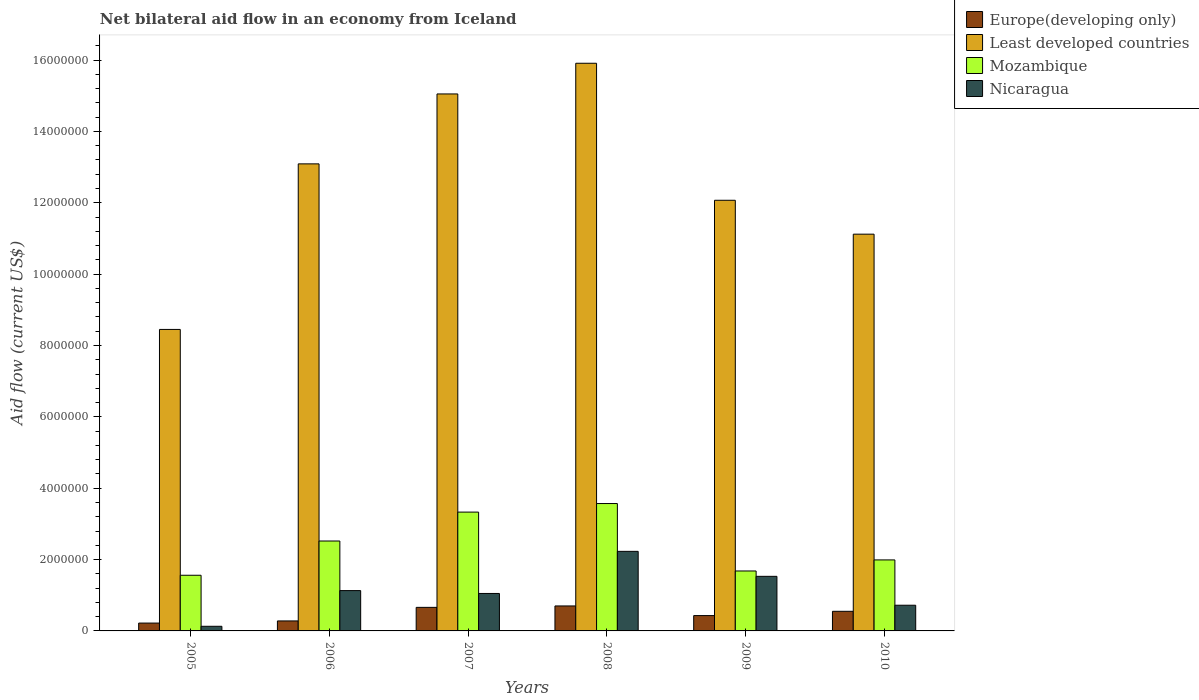How many different coloured bars are there?
Your response must be concise. 4. How many groups of bars are there?
Provide a short and direct response. 6. Are the number of bars per tick equal to the number of legend labels?
Provide a succinct answer. Yes. Are the number of bars on each tick of the X-axis equal?
Provide a succinct answer. Yes. How many bars are there on the 2nd tick from the right?
Make the answer very short. 4. What is the label of the 5th group of bars from the left?
Provide a succinct answer. 2009. What is the net bilateral aid flow in Least developed countries in 2006?
Offer a very short reply. 1.31e+07. Across all years, what is the maximum net bilateral aid flow in Mozambique?
Your answer should be very brief. 3.57e+06. What is the total net bilateral aid flow in Least developed countries in the graph?
Your answer should be compact. 7.57e+07. What is the difference between the net bilateral aid flow in Nicaragua in 2009 and that in 2010?
Offer a terse response. 8.10e+05. What is the difference between the net bilateral aid flow in Nicaragua in 2008 and the net bilateral aid flow in Least developed countries in 2006?
Keep it short and to the point. -1.09e+07. What is the average net bilateral aid flow in Nicaragua per year?
Your response must be concise. 1.13e+06. In the year 2006, what is the difference between the net bilateral aid flow in Mozambique and net bilateral aid flow in Nicaragua?
Your response must be concise. 1.39e+06. What is the ratio of the net bilateral aid flow in Nicaragua in 2007 to that in 2008?
Offer a very short reply. 0.47. Is the net bilateral aid flow in Europe(developing only) in 2008 less than that in 2009?
Keep it short and to the point. No. Is the difference between the net bilateral aid flow in Mozambique in 2009 and 2010 greater than the difference between the net bilateral aid flow in Nicaragua in 2009 and 2010?
Offer a terse response. No. What is the difference between the highest and the second highest net bilateral aid flow in Least developed countries?
Your answer should be very brief. 8.60e+05. What is the difference between the highest and the lowest net bilateral aid flow in Nicaragua?
Your response must be concise. 2.10e+06. Is the sum of the net bilateral aid flow in Mozambique in 2006 and 2009 greater than the maximum net bilateral aid flow in Least developed countries across all years?
Give a very brief answer. No. What does the 3rd bar from the left in 2005 represents?
Offer a terse response. Mozambique. What does the 3rd bar from the right in 2008 represents?
Give a very brief answer. Least developed countries. Does the graph contain any zero values?
Provide a succinct answer. No. Does the graph contain grids?
Your response must be concise. No. How are the legend labels stacked?
Make the answer very short. Vertical. What is the title of the graph?
Ensure brevity in your answer.  Net bilateral aid flow in an economy from Iceland. What is the label or title of the X-axis?
Give a very brief answer. Years. What is the Aid flow (current US$) of Europe(developing only) in 2005?
Make the answer very short. 2.20e+05. What is the Aid flow (current US$) in Least developed countries in 2005?
Your answer should be very brief. 8.45e+06. What is the Aid flow (current US$) in Mozambique in 2005?
Give a very brief answer. 1.56e+06. What is the Aid flow (current US$) in Least developed countries in 2006?
Offer a very short reply. 1.31e+07. What is the Aid flow (current US$) of Mozambique in 2006?
Offer a very short reply. 2.52e+06. What is the Aid flow (current US$) in Nicaragua in 2006?
Keep it short and to the point. 1.13e+06. What is the Aid flow (current US$) in Least developed countries in 2007?
Your answer should be very brief. 1.50e+07. What is the Aid flow (current US$) of Mozambique in 2007?
Your answer should be compact. 3.33e+06. What is the Aid flow (current US$) in Nicaragua in 2007?
Provide a succinct answer. 1.05e+06. What is the Aid flow (current US$) in Europe(developing only) in 2008?
Keep it short and to the point. 7.00e+05. What is the Aid flow (current US$) in Least developed countries in 2008?
Your response must be concise. 1.59e+07. What is the Aid flow (current US$) in Mozambique in 2008?
Offer a very short reply. 3.57e+06. What is the Aid flow (current US$) in Nicaragua in 2008?
Provide a short and direct response. 2.23e+06. What is the Aid flow (current US$) in Least developed countries in 2009?
Provide a short and direct response. 1.21e+07. What is the Aid flow (current US$) in Mozambique in 2009?
Make the answer very short. 1.68e+06. What is the Aid flow (current US$) in Nicaragua in 2009?
Your answer should be compact. 1.53e+06. What is the Aid flow (current US$) of Europe(developing only) in 2010?
Offer a terse response. 5.50e+05. What is the Aid flow (current US$) in Least developed countries in 2010?
Offer a terse response. 1.11e+07. What is the Aid flow (current US$) in Mozambique in 2010?
Offer a very short reply. 1.99e+06. What is the Aid flow (current US$) in Nicaragua in 2010?
Give a very brief answer. 7.20e+05. Across all years, what is the maximum Aid flow (current US$) of Europe(developing only)?
Provide a short and direct response. 7.00e+05. Across all years, what is the maximum Aid flow (current US$) of Least developed countries?
Give a very brief answer. 1.59e+07. Across all years, what is the maximum Aid flow (current US$) in Mozambique?
Provide a short and direct response. 3.57e+06. Across all years, what is the maximum Aid flow (current US$) in Nicaragua?
Make the answer very short. 2.23e+06. Across all years, what is the minimum Aid flow (current US$) of Least developed countries?
Provide a short and direct response. 8.45e+06. Across all years, what is the minimum Aid flow (current US$) of Mozambique?
Your response must be concise. 1.56e+06. Across all years, what is the minimum Aid flow (current US$) in Nicaragua?
Make the answer very short. 1.30e+05. What is the total Aid flow (current US$) in Europe(developing only) in the graph?
Ensure brevity in your answer.  2.84e+06. What is the total Aid flow (current US$) of Least developed countries in the graph?
Provide a succinct answer. 7.57e+07. What is the total Aid flow (current US$) of Mozambique in the graph?
Your answer should be very brief. 1.46e+07. What is the total Aid flow (current US$) of Nicaragua in the graph?
Provide a succinct answer. 6.79e+06. What is the difference between the Aid flow (current US$) in Europe(developing only) in 2005 and that in 2006?
Your answer should be very brief. -6.00e+04. What is the difference between the Aid flow (current US$) in Least developed countries in 2005 and that in 2006?
Ensure brevity in your answer.  -4.64e+06. What is the difference between the Aid flow (current US$) of Mozambique in 2005 and that in 2006?
Offer a terse response. -9.60e+05. What is the difference between the Aid flow (current US$) of Europe(developing only) in 2005 and that in 2007?
Ensure brevity in your answer.  -4.40e+05. What is the difference between the Aid flow (current US$) of Least developed countries in 2005 and that in 2007?
Your answer should be compact. -6.60e+06. What is the difference between the Aid flow (current US$) of Mozambique in 2005 and that in 2007?
Give a very brief answer. -1.77e+06. What is the difference between the Aid flow (current US$) of Nicaragua in 2005 and that in 2007?
Offer a terse response. -9.20e+05. What is the difference between the Aid flow (current US$) of Europe(developing only) in 2005 and that in 2008?
Provide a short and direct response. -4.80e+05. What is the difference between the Aid flow (current US$) in Least developed countries in 2005 and that in 2008?
Provide a short and direct response. -7.46e+06. What is the difference between the Aid flow (current US$) in Mozambique in 2005 and that in 2008?
Your answer should be compact. -2.01e+06. What is the difference between the Aid flow (current US$) of Nicaragua in 2005 and that in 2008?
Ensure brevity in your answer.  -2.10e+06. What is the difference between the Aid flow (current US$) in Least developed countries in 2005 and that in 2009?
Provide a short and direct response. -3.62e+06. What is the difference between the Aid flow (current US$) in Mozambique in 2005 and that in 2009?
Offer a terse response. -1.20e+05. What is the difference between the Aid flow (current US$) of Nicaragua in 2005 and that in 2009?
Your response must be concise. -1.40e+06. What is the difference between the Aid flow (current US$) of Europe(developing only) in 2005 and that in 2010?
Your answer should be very brief. -3.30e+05. What is the difference between the Aid flow (current US$) of Least developed countries in 2005 and that in 2010?
Give a very brief answer. -2.67e+06. What is the difference between the Aid flow (current US$) in Mozambique in 2005 and that in 2010?
Your answer should be very brief. -4.30e+05. What is the difference between the Aid flow (current US$) of Nicaragua in 2005 and that in 2010?
Your response must be concise. -5.90e+05. What is the difference between the Aid flow (current US$) in Europe(developing only) in 2006 and that in 2007?
Your response must be concise. -3.80e+05. What is the difference between the Aid flow (current US$) in Least developed countries in 2006 and that in 2007?
Your answer should be very brief. -1.96e+06. What is the difference between the Aid flow (current US$) in Mozambique in 2006 and that in 2007?
Your answer should be very brief. -8.10e+05. What is the difference between the Aid flow (current US$) of Europe(developing only) in 2006 and that in 2008?
Ensure brevity in your answer.  -4.20e+05. What is the difference between the Aid flow (current US$) in Least developed countries in 2006 and that in 2008?
Offer a very short reply. -2.82e+06. What is the difference between the Aid flow (current US$) of Mozambique in 2006 and that in 2008?
Provide a short and direct response. -1.05e+06. What is the difference between the Aid flow (current US$) of Nicaragua in 2006 and that in 2008?
Provide a succinct answer. -1.10e+06. What is the difference between the Aid flow (current US$) of Europe(developing only) in 2006 and that in 2009?
Your answer should be compact. -1.50e+05. What is the difference between the Aid flow (current US$) of Least developed countries in 2006 and that in 2009?
Keep it short and to the point. 1.02e+06. What is the difference between the Aid flow (current US$) of Mozambique in 2006 and that in 2009?
Your answer should be compact. 8.40e+05. What is the difference between the Aid flow (current US$) in Nicaragua in 2006 and that in 2009?
Give a very brief answer. -4.00e+05. What is the difference between the Aid flow (current US$) in Europe(developing only) in 2006 and that in 2010?
Your response must be concise. -2.70e+05. What is the difference between the Aid flow (current US$) in Least developed countries in 2006 and that in 2010?
Provide a succinct answer. 1.97e+06. What is the difference between the Aid flow (current US$) of Mozambique in 2006 and that in 2010?
Give a very brief answer. 5.30e+05. What is the difference between the Aid flow (current US$) in Nicaragua in 2006 and that in 2010?
Provide a succinct answer. 4.10e+05. What is the difference between the Aid flow (current US$) of Europe(developing only) in 2007 and that in 2008?
Provide a short and direct response. -4.00e+04. What is the difference between the Aid flow (current US$) of Least developed countries in 2007 and that in 2008?
Your answer should be compact. -8.60e+05. What is the difference between the Aid flow (current US$) in Nicaragua in 2007 and that in 2008?
Give a very brief answer. -1.18e+06. What is the difference between the Aid flow (current US$) of Least developed countries in 2007 and that in 2009?
Your answer should be compact. 2.98e+06. What is the difference between the Aid flow (current US$) of Mozambique in 2007 and that in 2009?
Give a very brief answer. 1.65e+06. What is the difference between the Aid flow (current US$) in Nicaragua in 2007 and that in 2009?
Provide a succinct answer. -4.80e+05. What is the difference between the Aid flow (current US$) of Europe(developing only) in 2007 and that in 2010?
Offer a very short reply. 1.10e+05. What is the difference between the Aid flow (current US$) in Least developed countries in 2007 and that in 2010?
Your response must be concise. 3.93e+06. What is the difference between the Aid flow (current US$) of Mozambique in 2007 and that in 2010?
Your answer should be compact. 1.34e+06. What is the difference between the Aid flow (current US$) of Europe(developing only) in 2008 and that in 2009?
Keep it short and to the point. 2.70e+05. What is the difference between the Aid flow (current US$) in Least developed countries in 2008 and that in 2009?
Your response must be concise. 3.84e+06. What is the difference between the Aid flow (current US$) of Mozambique in 2008 and that in 2009?
Provide a succinct answer. 1.89e+06. What is the difference between the Aid flow (current US$) of Nicaragua in 2008 and that in 2009?
Provide a succinct answer. 7.00e+05. What is the difference between the Aid flow (current US$) in Europe(developing only) in 2008 and that in 2010?
Give a very brief answer. 1.50e+05. What is the difference between the Aid flow (current US$) in Least developed countries in 2008 and that in 2010?
Offer a very short reply. 4.79e+06. What is the difference between the Aid flow (current US$) of Mozambique in 2008 and that in 2010?
Make the answer very short. 1.58e+06. What is the difference between the Aid flow (current US$) in Nicaragua in 2008 and that in 2010?
Ensure brevity in your answer.  1.51e+06. What is the difference between the Aid flow (current US$) of Europe(developing only) in 2009 and that in 2010?
Give a very brief answer. -1.20e+05. What is the difference between the Aid flow (current US$) of Least developed countries in 2009 and that in 2010?
Ensure brevity in your answer.  9.50e+05. What is the difference between the Aid flow (current US$) in Mozambique in 2009 and that in 2010?
Make the answer very short. -3.10e+05. What is the difference between the Aid flow (current US$) of Nicaragua in 2009 and that in 2010?
Your answer should be compact. 8.10e+05. What is the difference between the Aid flow (current US$) in Europe(developing only) in 2005 and the Aid flow (current US$) in Least developed countries in 2006?
Make the answer very short. -1.29e+07. What is the difference between the Aid flow (current US$) in Europe(developing only) in 2005 and the Aid flow (current US$) in Mozambique in 2006?
Offer a very short reply. -2.30e+06. What is the difference between the Aid flow (current US$) in Europe(developing only) in 2005 and the Aid flow (current US$) in Nicaragua in 2006?
Give a very brief answer. -9.10e+05. What is the difference between the Aid flow (current US$) in Least developed countries in 2005 and the Aid flow (current US$) in Mozambique in 2006?
Ensure brevity in your answer.  5.93e+06. What is the difference between the Aid flow (current US$) in Least developed countries in 2005 and the Aid flow (current US$) in Nicaragua in 2006?
Provide a succinct answer. 7.32e+06. What is the difference between the Aid flow (current US$) of Europe(developing only) in 2005 and the Aid flow (current US$) of Least developed countries in 2007?
Offer a terse response. -1.48e+07. What is the difference between the Aid flow (current US$) in Europe(developing only) in 2005 and the Aid flow (current US$) in Mozambique in 2007?
Make the answer very short. -3.11e+06. What is the difference between the Aid flow (current US$) of Europe(developing only) in 2005 and the Aid flow (current US$) of Nicaragua in 2007?
Offer a very short reply. -8.30e+05. What is the difference between the Aid flow (current US$) of Least developed countries in 2005 and the Aid flow (current US$) of Mozambique in 2007?
Give a very brief answer. 5.12e+06. What is the difference between the Aid flow (current US$) in Least developed countries in 2005 and the Aid flow (current US$) in Nicaragua in 2007?
Your response must be concise. 7.40e+06. What is the difference between the Aid flow (current US$) of Mozambique in 2005 and the Aid flow (current US$) of Nicaragua in 2007?
Provide a short and direct response. 5.10e+05. What is the difference between the Aid flow (current US$) of Europe(developing only) in 2005 and the Aid flow (current US$) of Least developed countries in 2008?
Your answer should be very brief. -1.57e+07. What is the difference between the Aid flow (current US$) of Europe(developing only) in 2005 and the Aid flow (current US$) of Mozambique in 2008?
Offer a very short reply. -3.35e+06. What is the difference between the Aid flow (current US$) of Europe(developing only) in 2005 and the Aid flow (current US$) of Nicaragua in 2008?
Provide a short and direct response. -2.01e+06. What is the difference between the Aid flow (current US$) of Least developed countries in 2005 and the Aid flow (current US$) of Mozambique in 2008?
Make the answer very short. 4.88e+06. What is the difference between the Aid flow (current US$) of Least developed countries in 2005 and the Aid flow (current US$) of Nicaragua in 2008?
Make the answer very short. 6.22e+06. What is the difference between the Aid flow (current US$) of Mozambique in 2005 and the Aid flow (current US$) of Nicaragua in 2008?
Provide a short and direct response. -6.70e+05. What is the difference between the Aid flow (current US$) of Europe(developing only) in 2005 and the Aid flow (current US$) of Least developed countries in 2009?
Offer a terse response. -1.18e+07. What is the difference between the Aid flow (current US$) in Europe(developing only) in 2005 and the Aid flow (current US$) in Mozambique in 2009?
Provide a short and direct response. -1.46e+06. What is the difference between the Aid flow (current US$) of Europe(developing only) in 2005 and the Aid flow (current US$) of Nicaragua in 2009?
Provide a succinct answer. -1.31e+06. What is the difference between the Aid flow (current US$) in Least developed countries in 2005 and the Aid flow (current US$) in Mozambique in 2009?
Make the answer very short. 6.77e+06. What is the difference between the Aid flow (current US$) in Least developed countries in 2005 and the Aid flow (current US$) in Nicaragua in 2009?
Provide a short and direct response. 6.92e+06. What is the difference between the Aid flow (current US$) in Europe(developing only) in 2005 and the Aid flow (current US$) in Least developed countries in 2010?
Keep it short and to the point. -1.09e+07. What is the difference between the Aid flow (current US$) of Europe(developing only) in 2005 and the Aid flow (current US$) of Mozambique in 2010?
Offer a very short reply. -1.77e+06. What is the difference between the Aid flow (current US$) in Europe(developing only) in 2005 and the Aid flow (current US$) in Nicaragua in 2010?
Provide a succinct answer. -5.00e+05. What is the difference between the Aid flow (current US$) of Least developed countries in 2005 and the Aid flow (current US$) of Mozambique in 2010?
Offer a very short reply. 6.46e+06. What is the difference between the Aid flow (current US$) of Least developed countries in 2005 and the Aid flow (current US$) of Nicaragua in 2010?
Ensure brevity in your answer.  7.73e+06. What is the difference between the Aid flow (current US$) in Mozambique in 2005 and the Aid flow (current US$) in Nicaragua in 2010?
Your answer should be compact. 8.40e+05. What is the difference between the Aid flow (current US$) in Europe(developing only) in 2006 and the Aid flow (current US$) in Least developed countries in 2007?
Provide a short and direct response. -1.48e+07. What is the difference between the Aid flow (current US$) of Europe(developing only) in 2006 and the Aid flow (current US$) of Mozambique in 2007?
Provide a short and direct response. -3.05e+06. What is the difference between the Aid flow (current US$) of Europe(developing only) in 2006 and the Aid flow (current US$) of Nicaragua in 2007?
Give a very brief answer. -7.70e+05. What is the difference between the Aid flow (current US$) of Least developed countries in 2006 and the Aid flow (current US$) of Mozambique in 2007?
Your answer should be compact. 9.76e+06. What is the difference between the Aid flow (current US$) in Least developed countries in 2006 and the Aid flow (current US$) in Nicaragua in 2007?
Ensure brevity in your answer.  1.20e+07. What is the difference between the Aid flow (current US$) of Mozambique in 2006 and the Aid flow (current US$) of Nicaragua in 2007?
Offer a terse response. 1.47e+06. What is the difference between the Aid flow (current US$) in Europe(developing only) in 2006 and the Aid flow (current US$) in Least developed countries in 2008?
Your answer should be very brief. -1.56e+07. What is the difference between the Aid flow (current US$) in Europe(developing only) in 2006 and the Aid flow (current US$) in Mozambique in 2008?
Provide a short and direct response. -3.29e+06. What is the difference between the Aid flow (current US$) of Europe(developing only) in 2006 and the Aid flow (current US$) of Nicaragua in 2008?
Offer a very short reply. -1.95e+06. What is the difference between the Aid flow (current US$) in Least developed countries in 2006 and the Aid flow (current US$) in Mozambique in 2008?
Ensure brevity in your answer.  9.52e+06. What is the difference between the Aid flow (current US$) of Least developed countries in 2006 and the Aid flow (current US$) of Nicaragua in 2008?
Your answer should be very brief. 1.09e+07. What is the difference between the Aid flow (current US$) in Europe(developing only) in 2006 and the Aid flow (current US$) in Least developed countries in 2009?
Your answer should be very brief. -1.18e+07. What is the difference between the Aid flow (current US$) in Europe(developing only) in 2006 and the Aid flow (current US$) in Mozambique in 2009?
Your answer should be compact. -1.40e+06. What is the difference between the Aid flow (current US$) in Europe(developing only) in 2006 and the Aid flow (current US$) in Nicaragua in 2009?
Provide a short and direct response. -1.25e+06. What is the difference between the Aid flow (current US$) of Least developed countries in 2006 and the Aid flow (current US$) of Mozambique in 2009?
Provide a short and direct response. 1.14e+07. What is the difference between the Aid flow (current US$) in Least developed countries in 2006 and the Aid flow (current US$) in Nicaragua in 2009?
Your response must be concise. 1.16e+07. What is the difference between the Aid flow (current US$) in Mozambique in 2006 and the Aid flow (current US$) in Nicaragua in 2009?
Keep it short and to the point. 9.90e+05. What is the difference between the Aid flow (current US$) of Europe(developing only) in 2006 and the Aid flow (current US$) of Least developed countries in 2010?
Your response must be concise. -1.08e+07. What is the difference between the Aid flow (current US$) in Europe(developing only) in 2006 and the Aid flow (current US$) in Mozambique in 2010?
Offer a very short reply. -1.71e+06. What is the difference between the Aid flow (current US$) in Europe(developing only) in 2006 and the Aid flow (current US$) in Nicaragua in 2010?
Keep it short and to the point. -4.40e+05. What is the difference between the Aid flow (current US$) in Least developed countries in 2006 and the Aid flow (current US$) in Mozambique in 2010?
Provide a short and direct response. 1.11e+07. What is the difference between the Aid flow (current US$) in Least developed countries in 2006 and the Aid flow (current US$) in Nicaragua in 2010?
Keep it short and to the point. 1.24e+07. What is the difference between the Aid flow (current US$) in Mozambique in 2006 and the Aid flow (current US$) in Nicaragua in 2010?
Provide a succinct answer. 1.80e+06. What is the difference between the Aid flow (current US$) in Europe(developing only) in 2007 and the Aid flow (current US$) in Least developed countries in 2008?
Your answer should be very brief. -1.52e+07. What is the difference between the Aid flow (current US$) in Europe(developing only) in 2007 and the Aid flow (current US$) in Mozambique in 2008?
Provide a succinct answer. -2.91e+06. What is the difference between the Aid flow (current US$) in Europe(developing only) in 2007 and the Aid flow (current US$) in Nicaragua in 2008?
Your answer should be compact. -1.57e+06. What is the difference between the Aid flow (current US$) of Least developed countries in 2007 and the Aid flow (current US$) of Mozambique in 2008?
Make the answer very short. 1.15e+07. What is the difference between the Aid flow (current US$) of Least developed countries in 2007 and the Aid flow (current US$) of Nicaragua in 2008?
Provide a short and direct response. 1.28e+07. What is the difference between the Aid flow (current US$) in Mozambique in 2007 and the Aid flow (current US$) in Nicaragua in 2008?
Make the answer very short. 1.10e+06. What is the difference between the Aid flow (current US$) of Europe(developing only) in 2007 and the Aid flow (current US$) of Least developed countries in 2009?
Offer a terse response. -1.14e+07. What is the difference between the Aid flow (current US$) in Europe(developing only) in 2007 and the Aid flow (current US$) in Mozambique in 2009?
Offer a very short reply. -1.02e+06. What is the difference between the Aid flow (current US$) in Europe(developing only) in 2007 and the Aid flow (current US$) in Nicaragua in 2009?
Your answer should be compact. -8.70e+05. What is the difference between the Aid flow (current US$) in Least developed countries in 2007 and the Aid flow (current US$) in Mozambique in 2009?
Your answer should be compact. 1.34e+07. What is the difference between the Aid flow (current US$) of Least developed countries in 2007 and the Aid flow (current US$) of Nicaragua in 2009?
Ensure brevity in your answer.  1.35e+07. What is the difference between the Aid flow (current US$) in Mozambique in 2007 and the Aid flow (current US$) in Nicaragua in 2009?
Give a very brief answer. 1.80e+06. What is the difference between the Aid flow (current US$) in Europe(developing only) in 2007 and the Aid flow (current US$) in Least developed countries in 2010?
Make the answer very short. -1.05e+07. What is the difference between the Aid flow (current US$) of Europe(developing only) in 2007 and the Aid flow (current US$) of Mozambique in 2010?
Keep it short and to the point. -1.33e+06. What is the difference between the Aid flow (current US$) of Europe(developing only) in 2007 and the Aid flow (current US$) of Nicaragua in 2010?
Your response must be concise. -6.00e+04. What is the difference between the Aid flow (current US$) in Least developed countries in 2007 and the Aid flow (current US$) in Mozambique in 2010?
Offer a terse response. 1.31e+07. What is the difference between the Aid flow (current US$) in Least developed countries in 2007 and the Aid flow (current US$) in Nicaragua in 2010?
Offer a very short reply. 1.43e+07. What is the difference between the Aid flow (current US$) of Mozambique in 2007 and the Aid flow (current US$) of Nicaragua in 2010?
Provide a succinct answer. 2.61e+06. What is the difference between the Aid flow (current US$) of Europe(developing only) in 2008 and the Aid flow (current US$) of Least developed countries in 2009?
Your response must be concise. -1.14e+07. What is the difference between the Aid flow (current US$) in Europe(developing only) in 2008 and the Aid flow (current US$) in Mozambique in 2009?
Ensure brevity in your answer.  -9.80e+05. What is the difference between the Aid flow (current US$) in Europe(developing only) in 2008 and the Aid flow (current US$) in Nicaragua in 2009?
Offer a very short reply. -8.30e+05. What is the difference between the Aid flow (current US$) of Least developed countries in 2008 and the Aid flow (current US$) of Mozambique in 2009?
Your answer should be very brief. 1.42e+07. What is the difference between the Aid flow (current US$) of Least developed countries in 2008 and the Aid flow (current US$) of Nicaragua in 2009?
Your response must be concise. 1.44e+07. What is the difference between the Aid flow (current US$) of Mozambique in 2008 and the Aid flow (current US$) of Nicaragua in 2009?
Give a very brief answer. 2.04e+06. What is the difference between the Aid flow (current US$) in Europe(developing only) in 2008 and the Aid flow (current US$) in Least developed countries in 2010?
Give a very brief answer. -1.04e+07. What is the difference between the Aid flow (current US$) in Europe(developing only) in 2008 and the Aid flow (current US$) in Mozambique in 2010?
Provide a short and direct response. -1.29e+06. What is the difference between the Aid flow (current US$) of Europe(developing only) in 2008 and the Aid flow (current US$) of Nicaragua in 2010?
Provide a short and direct response. -2.00e+04. What is the difference between the Aid flow (current US$) of Least developed countries in 2008 and the Aid flow (current US$) of Mozambique in 2010?
Ensure brevity in your answer.  1.39e+07. What is the difference between the Aid flow (current US$) in Least developed countries in 2008 and the Aid flow (current US$) in Nicaragua in 2010?
Your answer should be very brief. 1.52e+07. What is the difference between the Aid flow (current US$) of Mozambique in 2008 and the Aid flow (current US$) of Nicaragua in 2010?
Your answer should be compact. 2.85e+06. What is the difference between the Aid flow (current US$) in Europe(developing only) in 2009 and the Aid flow (current US$) in Least developed countries in 2010?
Offer a terse response. -1.07e+07. What is the difference between the Aid flow (current US$) of Europe(developing only) in 2009 and the Aid flow (current US$) of Mozambique in 2010?
Offer a very short reply. -1.56e+06. What is the difference between the Aid flow (current US$) of Europe(developing only) in 2009 and the Aid flow (current US$) of Nicaragua in 2010?
Your answer should be very brief. -2.90e+05. What is the difference between the Aid flow (current US$) in Least developed countries in 2009 and the Aid flow (current US$) in Mozambique in 2010?
Offer a very short reply. 1.01e+07. What is the difference between the Aid flow (current US$) in Least developed countries in 2009 and the Aid flow (current US$) in Nicaragua in 2010?
Offer a terse response. 1.14e+07. What is the difference between the Aid flow (current US$) in Mozambique in 2009 and the Aid flow (current US$) in Nicaragua in 2010?
Provide a short and direct response. 9.60e+05. What is the average Aid flow (current US$) of Europe(developing only) per year?
Your answer should be compact. 4.73e+05. What is the average Aid flow (current US$) in Least developed countries per year?
Keep it short and to the point. 1.26e+07. What is the average Aid flow (current US$) of Mozambique per year?
Your answer should be compact. 2.44e+06. What is the average Aid flow (current US$) of Nicaragua per year?
Provide a short and direct response. 1.13e+06. In the year 2005, what is the difference between the Aid flow (current US$) in Europe(developing only) and Aid flow (current US$) in Least developed countries?
Keep it short and to the point. -8.23e+06. In the year 2005, what is the difference between the Aid flow (current US$) in Europe(developing only) and Aid flow (current US$) in Mozambique?
Your answer should be compact. -1.34e+06. In the year 2005, what is the difference between the Aid flow (current US$) in Least developed countries and Aid flow (current US$) in Mozambique?
Keep it short and to the point. 6.89e+06. In the year 2005, what is the difference between the Aid flow (current US$) of Least developed countries and Aid flow (current US$) of Nicaragua?
Ensure brevity in your answer.  8.32e+06. In the year 2005, what is the difference between the Aid flow (current US$) in Mozambique and Aid flow (current US$) in Nicaragua?
Your answer should be very brief. 1.43e+06. In the year 2006, what is the difference between the Aid flow (current US$) in Europe(developing only) and Aid flow (current US$) in Least developed countries?
Provide a short and direct response. -1.28e+07. In the year 2006, what is the difference between the Aid flow (current US$) in Europe(developing only) and Aid flow (current US$) in Mozambique?
Keep it short and to the point. -2.24e+06. In the year 2006, what is the difference between the Aid flow (current US$) in Europe(developing only) and Aid flow (current US$) in Nicaragua?
Give a very brief answer. -8.50e+05. In the year 2006, what is the difference between the Aid flow (current US$) of Least developed countries and Aid flow (current US$) of Mozambique?
Give a very brief answer. 1.06e+07. In the year 2006, what is the difference between the Aid flow (current US$) of Least developed countries and Aid flow (current US$) of Nicaragua?
Your answer should be very brief. 1.20e+07. In the year 2006, what is the difference between the Aid flow (current US$) of Mozambique and Aid flow (current US$) of Nicaragua?
Make the answer very short. 1.39e+06. In the year 2007, what is the difference between the Aid flow (current US$) in Europe(developing only) and Aid flow (current US$) in Least developed countries?
Offer a very short reply. -1.44e+07. In the year 2007, what is the difference between the Aid flow (current US$) of Europe(developing only) and Aid flow (current US$) of Mozambique?
Give a very brief answer. -2.67e+06. In the year 2007, what is the difference between the Aid flow (current US$) in Europe(developing only) and Aid flow (current US$) in Nicaragua?
Make the answer very short. -3.90e+05. In the year 2007, what is the difference between the Aid flow (current US$) in Least developed countries and Aid flow (current US$) in Mozambique?
Your answer should be compact. 1.17e+07. In the year 2007, what is the difference between the Aid flow (current US$) of Least developed countries and Aid flow (current US$) of Nicaragua?
Your answer should be compact. 1.40e+07. In the year 2007, what is the difference between the Aid flow (current US$) in Mozambique and Aid flow (current US$) in Nicaragua?
Provide a short and direct response. 2.28e+06. In the year 2008, what is the difference between the Aid flow (current US$) of Europe(developing only) and Aid flow (current US$) of Least developed countries?
Make the answer very short. -1.52e+07. In the year 2008, what is the difference between the Aid flow (current US$) in Europe(developing only) and Aid flow (current US$) in Mozambique?
Provide a succinct answer. -2.87e+06. In the year 2008, what is the difference between the Aid flow (current US$) of Europe(developing only) and Aid flow (current US$) of Nicaragua?
Make the answer very short. -1.53e+06. In the year 2008, what is the difference between the Aid flow (current US$) in Least developed countries and Aid flow (current US$) in Mozambique?
Your answer should be very brief. 1.23e+07. In the year 2008, what is the difference between the Aid flow (current US$) of Least developed countries and Aid flow (current US$) of Nicaragua?
Give a very brief answer. 1.37e+07. In the year 2008, what is the difference between the Aid flow (current US$) of Mozambique and Aid flow (current US$) of Nicaragua?
Make the answer very short. 1.34e+06. In the year 2009, what is the difference between the Aid flow (current US$) of Europe(developing only) and Aid flow (current US$) of Least developed countries?
Offer a very short reply. -1.16e+07. In the year 2009, what is the difference between the Aid flow (current US$) in Europe(developing only) and Aid flow (current US$) in Mozambique?
Provide a short and direct response. -1.25e+06. In the year 2009, what is the difference between the Aid flow (current US$) of Europe(developing only) and Aid flow (current US$) of Nicaragua?
Your answer should be very brief. -1.10e+06. In the year 2009, what is the difference between the Aid flow (current US$) in Least developed countries and Aid flow (current US$) in Mozambique?
Ensure brevity in your answer.  1.04e+07. In the year 2009, what is the difference between the Aid flow (current US$) in Least developed countries and Aid flow (current US$) in Nicaragua?
Provide a short and direct response. 1.05e+07. In the year 2009, what is the difference between the Aid flow (current US$) in Mozambique and Aid flow (current US$) in Nicaragua?
Give a very brief answer. 1.50e+05. In the year 2010, what is the difference between the Aid flow (current US$) in Europe(developing only) and Aid flow (current US$) in Least developed countries?
Offer a terse response. -1.06e+07. In the year 2010, what is the difference between the Aid flow (current US$) in Europe(developing only) and Aid flow (current US$) in Mozambique?
Make the answer very short. -1.44e+06. In the year 2010, what is the difference between the Aid flow (current US$) in Europe(developing only) and Aid flow (current US$) in Nicaragua?
Provide a short and direct response. -1.70e+05. In the year 2010, what is the difference between the Aid flow (current US$) of Least developed countries and Aid flow (current US$) of Mozambique?
Provide a succinct answer. 9.13e+06. In the year 2010, what is the difference between the Aid flow (current US$) in Least developed countries and Aid flow (current US$) in Nicaragua?
Ensure brevity in your answer.  1.04e+07. In the year 2010, what is the difference between the Aid flow (current US$) in Mozambique and Aid flow (current US$) in Nicaragua?
Give a very brief answer. 1.27e+06. What is the ratio of the Aid flow (current US$) in Europe(developing only) in 2005 to that in 2006?
Make the answer very short. 0.79. What is the ratio of the Aid flow (current US$) of Least developed countries in 2005 to that in 2006?
Provide a short and direct response. 0.65. What is the ratio of the Aid flow (current US$) in Mozambique in 2005 to that in 2006?
Give a very brief answer. 0.62. What is the ratio of the Aid flow (current US$) in Nicaragua in 2005 to that in 2006?
Offer a very short reply. 0.12. What is the ratio of the Aid flow (current US$) in Least developed countries in 2005 to that in 2007?
Provide a succinct answer. 0.56. What is the ratio of the Aid flow (current US$) in Mozambique in 2005 to that in 2007?
Ensure brevity in your answer.  0.47. What is the ratio of the Aid flow (current US$) in Nicaragua in 2005 to that in 2007?
Your answer should be very brief. 0.12. What is the ratio of the Aid flow (current US$) of Europe(developing only) in 2005 to that in 2008?
Ensure brevity in your answer.  0.31. What is the ratio of the Aid flow (current US$) of Least developed countries in 2005 to that in 2008?
Offer a terse response. 0.53. What is the ratio of the Aid flow (current US$) in Mozambique in 2005 to that in 2008?
Offer a very short reply. 0.44. What is the ratio of the Aid flow (current US$) of Nicaragua in 2005 to that in 2008?
Provide a short and direct response. 0.06. What is the ratio of the Aid flow (current US$) of Europe(developing only) in 2005 to that in 2009?
Make the answer very short. 0.51. What is the ratio of the Aid flow (current US$) in Least developed countries in 2005 to that in 2009?
Your response must be concise. 0.7. What is the ratio of the Aid flow (current US$) of Mozambique in 2005 to that in 2009?
Offer a terse response. 0.93. What is the ratio of the Aid flow (current US$) of Nicaragua in 2005 to that in 2009?
Offer a terse response. 0.09. What is the ratio of the Aid flow (current US$) of Least developed countries in 2005 to that in 2010?
Provide a succinct answer. 0.76. What is the ratio of the Aid flow (current US$) in Mozambique in 2005 to that in 2010?
Offer a very short reply. 0.78. What is the ratio of the Aid flow (current US$) in Nicaragua in 2005 to that in 2010?
Keep it short and to the point. 0.18. What is the ratio of the Aid flow (current US$) in Europe(developing only) in 2006 to that in 2007?
Keep it short and to the point. 0.42. What is the ratio of the Aid flow (current US$) in Least developed countries in 2006 to that in 2007?
Provide a short and direct response. 0.87. What is the ratio of the Aid flow (current US$) of Mozambique in 2006 to that in 2007?
Ensure brevity in your answer.  0.76. What is the ratio of the Aid flow (current US$) of Nicaragua in 2006 to that in 2007?
Your answer should be very brief. 1.08. What is the ratio of the Aid flow (current US$) of Europe(developing only) in 2006 to that in 2008?
Keep it short and to the point. 0.4. What is the ratio of the Aid flow (current US$) in Least developed countries in 2006 to that in 2008?
Your response must be concise. 0.82. What is the ratio of the Aid flow (current US$) of Mozambique in 2006 to that in 2008?
Your response must be concise. 0.71. What is the ratio of the Aid flow (current US$) in Nicaragua in 2006 to that in 2008?
Your response must be concise. 0.51. What is the ratio of the Aid flow (current US$) of Europe(developing only) in 2006 to that in 2009?
Provide a short and direct response. 0.65. What is the ratio of the Aid flow (current US$) of Least developed countries in 2006 to that in 2009?
Your answer should be compact. 1.08. What is the ratio of the Aid flow (current US$) in Nicaragua in 2006 to that in 2009?
Give a very brief answer. 0.74. What is the ratio of the Aid flow (current US$) in Europe(developing only) in 2006 to that in 2010?
Your response must be concise. 0.51. What is the ratio of the Aid flow (current US$) in Least developed countries in 2006 to that in 2010?
Your response must be concise. 1.18. What is the ratio of the Aid flow (current US$) of Mozambique in 2006 to that in 2010?
Ensure brevity in your answer.  1.27. What is the ratio of the Aid flow (current US$) in Nicaragua in 2006 to that in 2010?
Provide a short and direct response. 1.57. What is the ratio of the Aid flow (current US$) in Europe(developing only) in 2007 to that in 2008?
Provide a short and direct response. 0.94. What is the ratio of the Aid flow (current US$) in Least developed countries in 2007 to that in 2008?
Provide a short and direct response. 0.95. What is the ratio of the Aid flow (current US$) in Mozambique in 2007 to that in 2008?
Ensure brevity in your answer.  0.93. What is the ratio of the Aid flow (current US$) in Nicaragua in 2007 to that in 2008?
Give a very brief answer. 0.47. What is the ratio of the Aid flow (current US$) in Europe(developing only) in 2007 to that in 2009?
Your response must be concise. 1.53. What is the ratio of the Aid flow (current US$) in Least developed countries in 2007 to that in 2009?
Your response must be concise. 1.25. What is the ratio of the Aid flow (current US$) of Mozambique in 2007 to that in 2009?
Offer a terse response. 1.98. What is the ratio of the Aid flow (current US$) in Nicaragua in 2007 to that in 2009?
Give a very brief answer. 0.69. What is the ratio of the Aid flow (current US$) of Europe(developing only) in 2007 to that in 2010?
Offer a terse response. 1.2. What is the ratio of the Aid flow (current US$) of Least developed countries in 2007 to that in 2010?
Offer a very short reply. 1.35. What is the ratio of the Aid flow (current US$) in Mozambique in 2007 to that in 2010?
Give a very brief answer. 1.67. What is the ratio of the Aid flow (current US$) of Nicaragua in 2007 to that in 2010?
Provide a short and direct response. 1.46. What is the ratio of the Aid flow (current US$) in Europe(developing only) in 2008 to that in 2009?
Your answer should be compact. 1.63. What is the ratio of the Aid flow (current US$) in Least developed countries in 2008 to that in 2009?
Give a very brief answer. 1.32. What is the ratio of the Aid flow (current US$) in Mozambique in 2008 to that in 2009?
Provide a succinct answer. 2.12. What is the ratio of the Aid flow (current US$) of Nicaragua in 2008 to that in 2009?
Your response must be concise. 1.46. What is the ratio of the Aid flow (current US$) of Europe(developing only) in 2008 to that in 2010?
Provide a short and direct response. 1.27. What is the ratio of the Aid flow (current US$) in Least developed countries in 2008 to that in 2010?
Offer a very short reply. 1.43. What is the ratio of the Aid flow (current US$) in Mozambique in 2008 to that in 2010?
Your answer should be very brief. 1.79. What is the ratio of the Aid flow (current US$) in Nicaragua in 2008 to that in 2010?
Keep it short and to the point. 3.1. What is the ratio of the Aid flow (current US$) of Europe(developing only) in 2009 to that in 2010?
Make the answer very short. 0.78. What is the ratio of the Aid flow (current US$) of Least developed countries in 2009 to that in 2010?
Make the answer very short. 1.09. What is the ratio of the Aid flow (current US$) of Mozambique in 2009 to that in 2010?
Make the answer very short. 0.84. What is the ratio of the Aid flow (current US$) in Nicaragua in 2009 to that in 2010?
Your response must be concise. 2.12. What is the difference between the highest and the second highest Aid flow (current US$) in Europe(developing only)?
Ensure brevity in your answer.  4.00e+04. What is the difference between the highest and the second highest Aid flow (current US$) in Least developed countries?
Your response must be concise. 8.60e+05. What is the difference between the highest and the lowest Aid flow (current US$) of Europe(developing only)?
Keep it short and to the point. 4.80e+05. What is the difference between the highest and the lowest Aid flow (current US$) of Least developed countries?
Provide a short and direct response. 7.46e+06. What is the difference between the highest and the lowest Aid flow (current US$) in Mozambique?
Offer a very short reply. 2.01e+06. What is the difference between the highest and the lowest Aid flow (current US$) in Nicaragua?
Ensure brevity in your answer.  2.10e+06. 